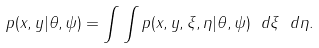Convert formula to latex. <formula><loc_0><loc_0><loc_500><loc_500>p ( x , y | \theta , \psi ) = \int \int p ( x , y , \xi , \eta | \theta , \psi ) \ d \xi \ d \eta .</formula> 